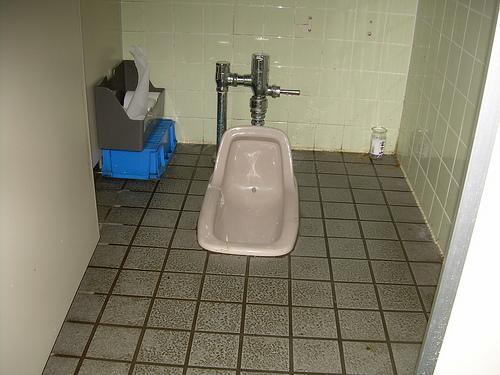How many people are wearing glasses?
Give a very brief answer. 0. 